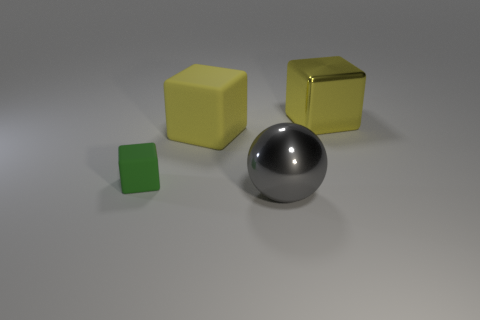How many objects are in the image? There are four objects in the image: two yellow cubes, one green cube, and one silver spherical object. 